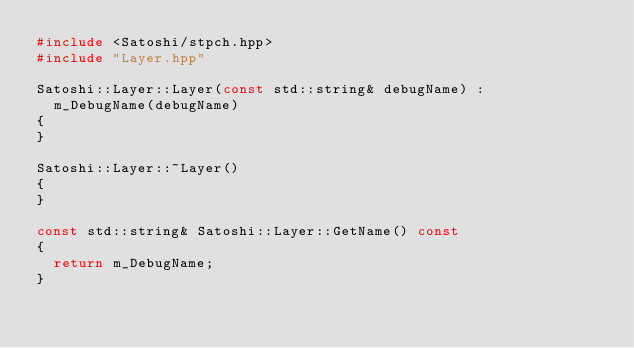<code> <loc_0><loc_0><loc_500><loc_500><_C++_>#include <Satoshi/stpch.hpp>
#include "Layer.hpp"

Satoshi::Layer::Layer(const std::string& debugName) :
	m_DebugName(debugName)
{
}

Satoshi::Layer::~Layer()
{
}

const std::string& Satoshi::Layer::GetName() const
{
	return m_DebugName;
}
</code> 